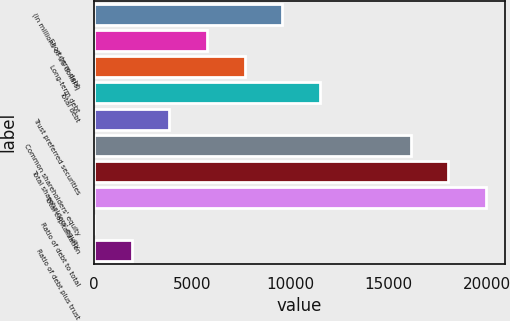Convert chart to OTSL. <chart><loc_0><loc_0><loc_500><loc_500><bar_chart><fcel>(in millions of US dollars)<fcel>Short-term debt<fcel>Long-term debt<fcel>Total debt<fcel>Trust preferred securities<fcel>Common shareholders' equity<fcel>Total shareholders' equity<fcel>Total capitalization<fcel>Ratio of debt to total<fcel>Ratio of debt plus trust<nl><fcel>9590.2<fcel>5758.68<fcel>7674.44<fcel>11506<fcel>3842.92<fcel>16120<fcel>18035.8<fcel>19951.5<fcel>11.4<fcel>1927.16<nl></chart> 